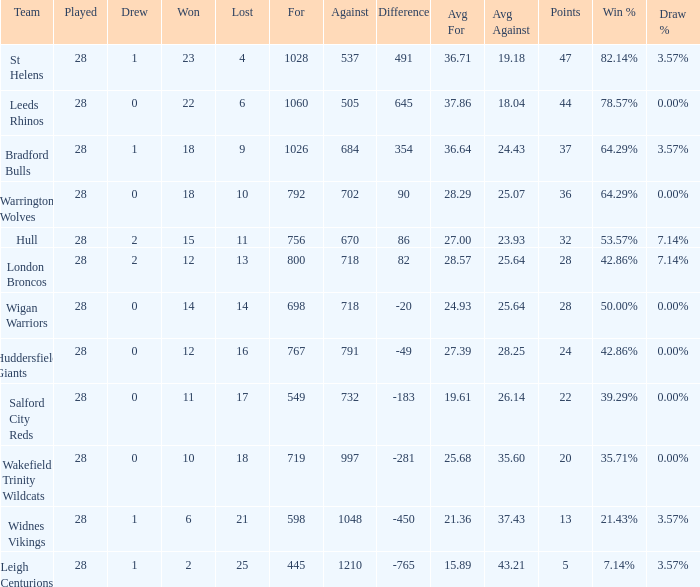What is the highest difference for the team that had less than 0 draws? None. 